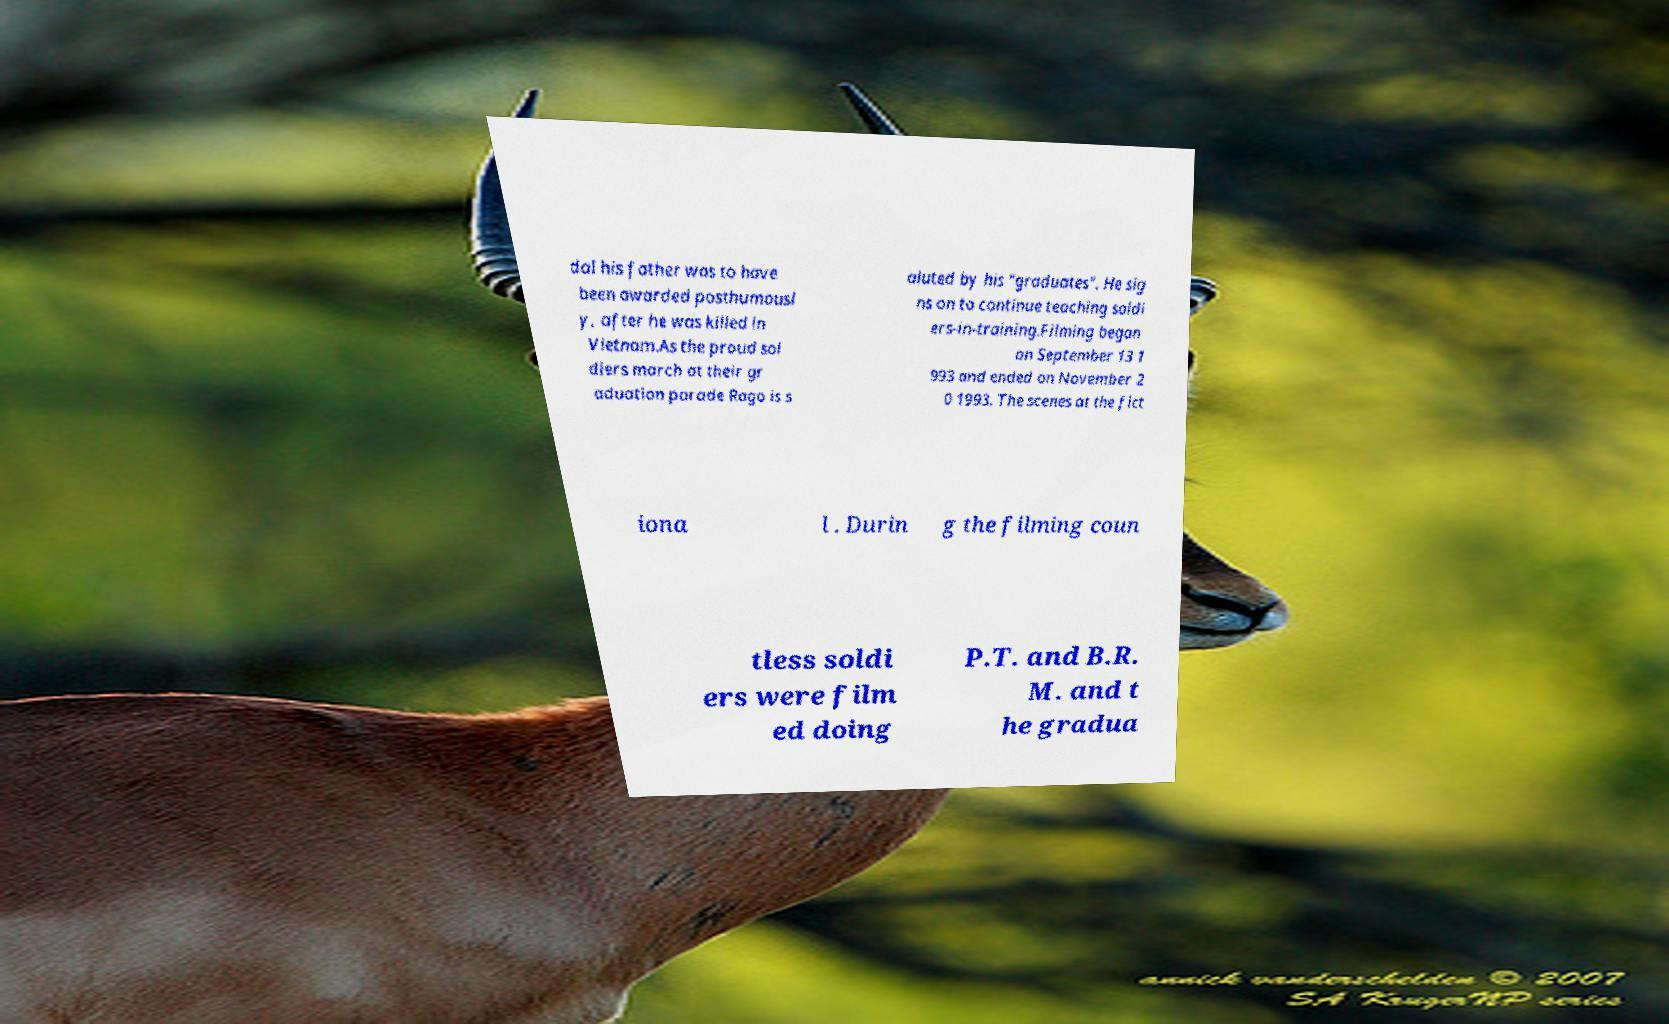Please read and relay the text visible in this image. What does it say? dal his father was to have been awarded posthumousl y, after he was killed in Vietnam.As the proud sol diers march at their gr aduation parade Rago is s aluted by his "graduates". He sig ns on to continue teaching soldi ers-in-training.Filming began on September 13 1 993 and ended on November 2 0 1993. The scenes at the fict iona l . Durin g the filming coun tless soldi ers were film ed doing P.T. and B.R. M. and t he gradua 